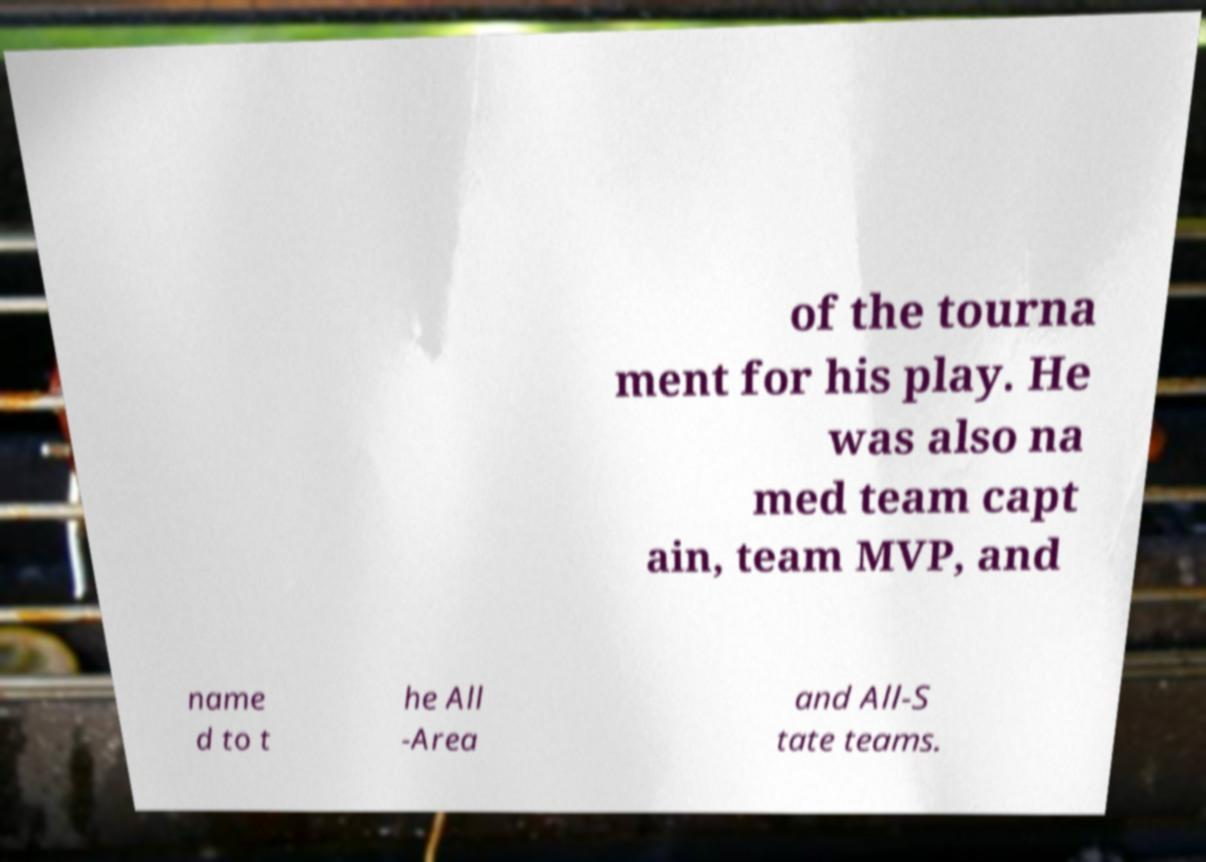Could you extract and type out the text from this image? of the tourna ment for his play. He was also na med team capt ain, team MVP, and name d to t he All -Area and All-S tate teams. 